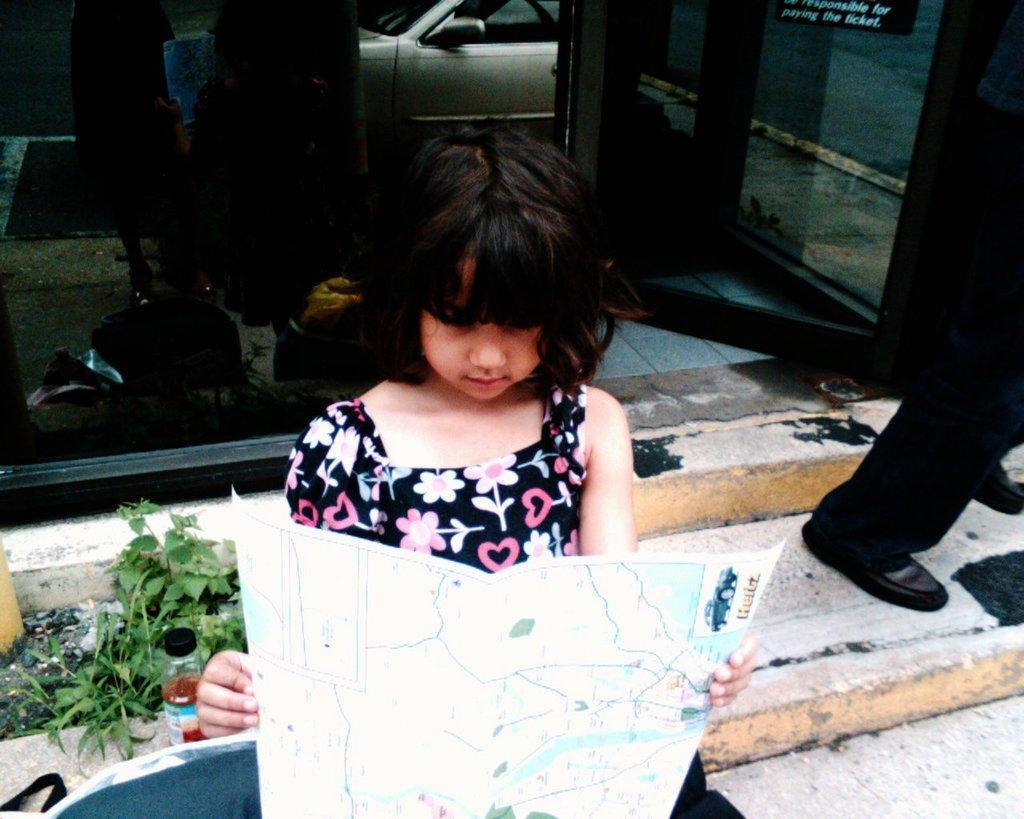How would you summarize this image in a sentence or two? At the bottom of the picture we can see a girl holding a map, beside her there are plants, soil wall and other objects. On the right we can see a person standing. At the top there are glass door, chair, car and a board. 